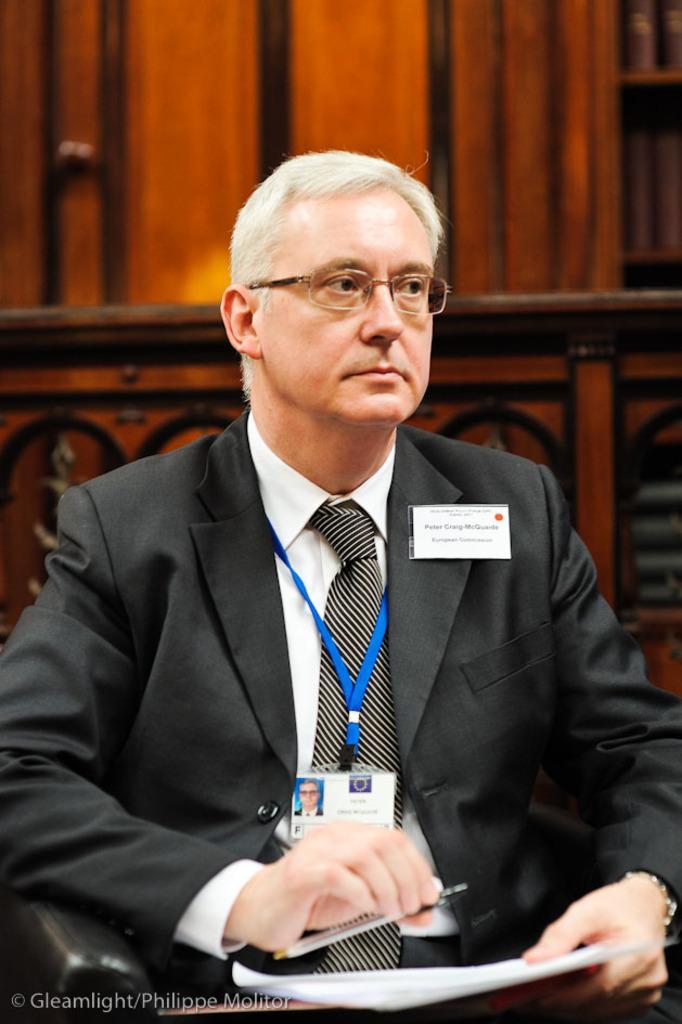Can you describe this image briefly? In the picture we can see a man sitting in the chair and he is in blazer, tie and shirt and he is holding a pen and a paper and behind him we can see the wooden wall with some designs on it. 